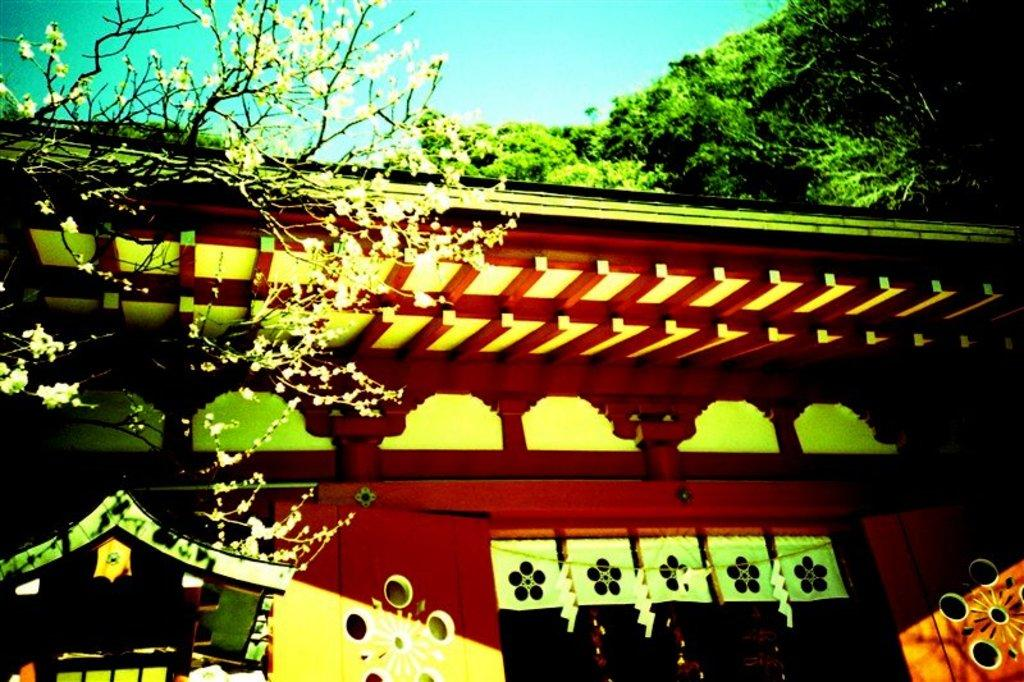What type of vegetation is on the left side of the image? There are leaves and stems on the left side of the image. What can be seen in the background of the image? There is a building and trees in the background of the image. What is the color of the sky in the image? The sky is blue in color. What type of secretary can be seen working in the image? There is no secretary present in the image. What invention is being used by the ants in the image? There are no ants or inventions present in the image. 